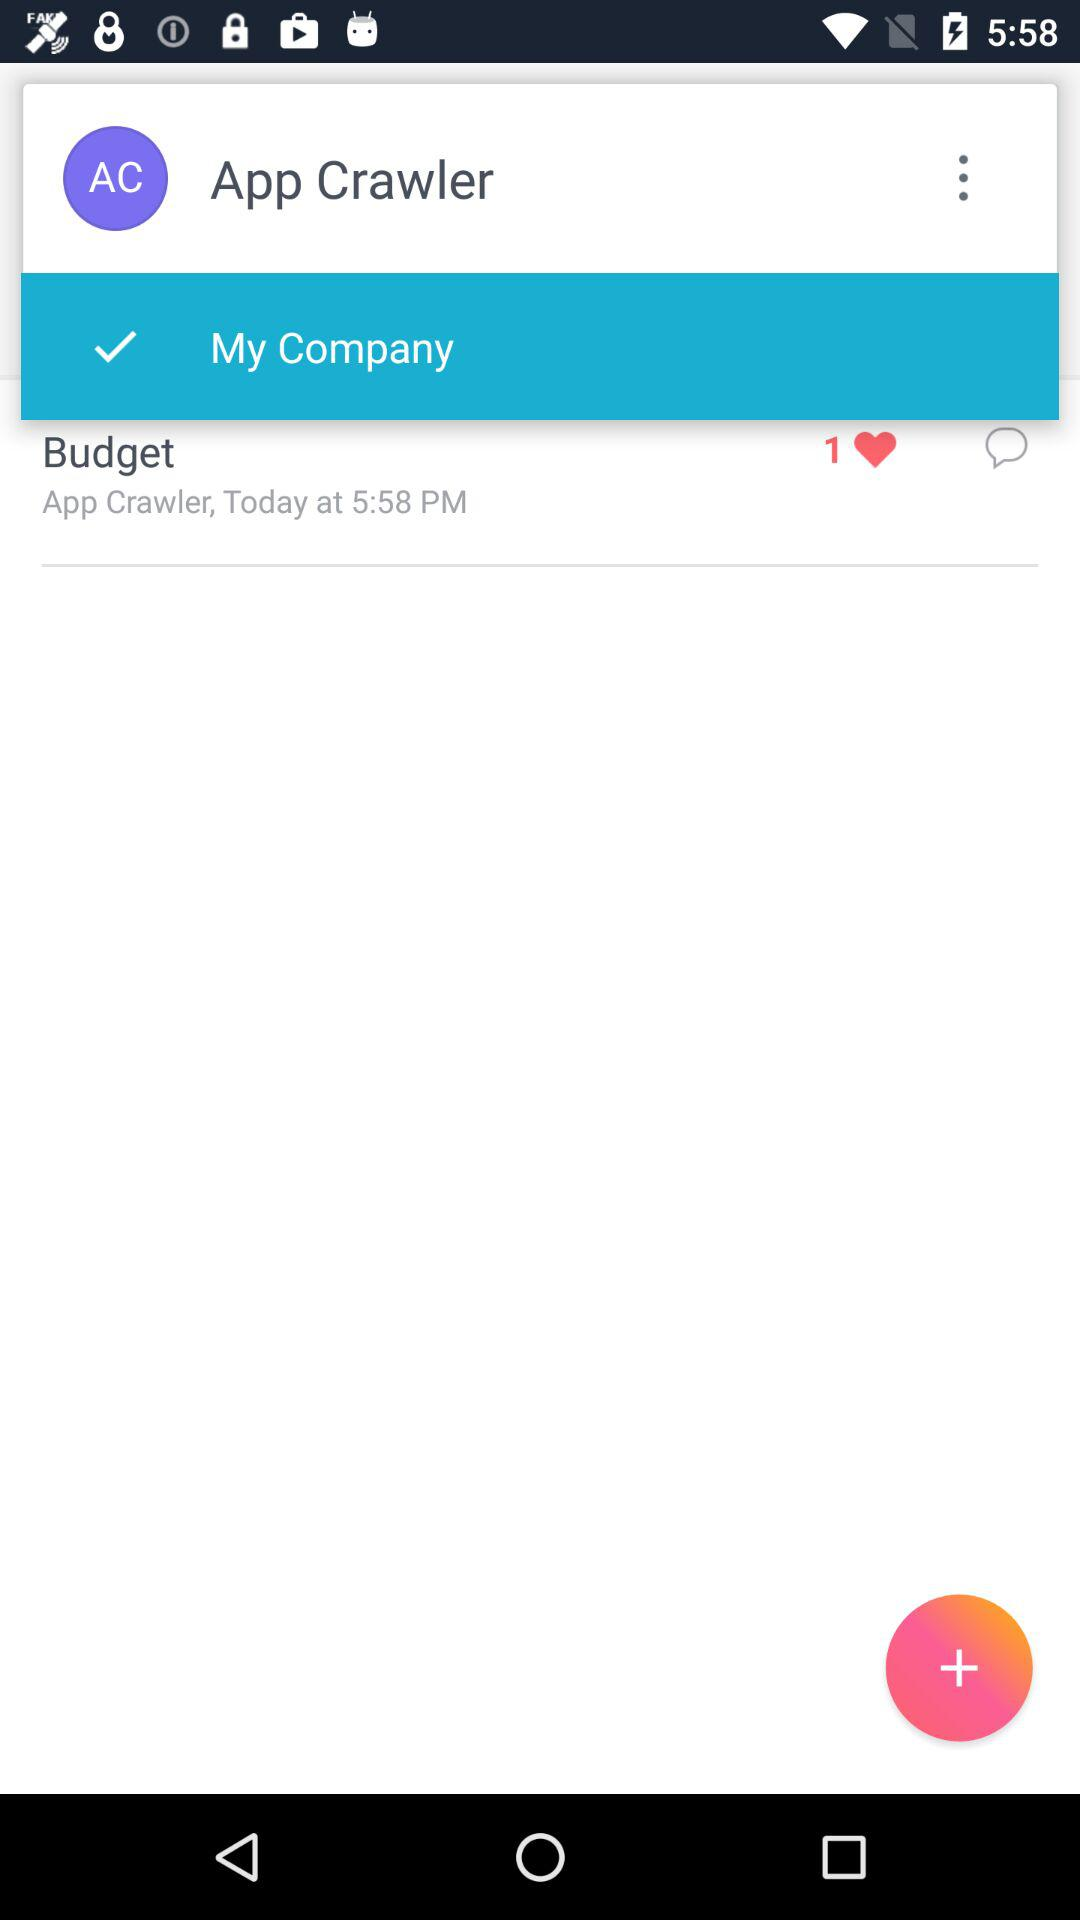What's the checked option? The checked option is "My Company". 